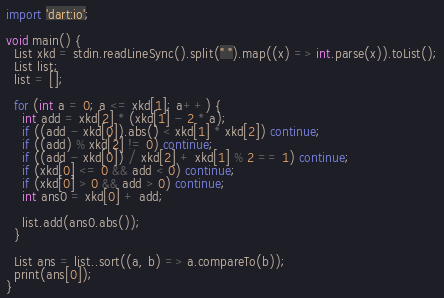Convert code to text. <code><loc_0><loc_0><loc_500><loc_500><_Dart_>import 'dart:io';

void main() {
  List xkd = stdin.readLineSync().split(" ").map((x) => int.parse(x)).toList();
  List list;
  list = [];

  for (int a = 0; a <= xkd[1]; a++) {
    int add = xkd[2] * (xkd[1] - 2 * a);
    if ((add - xkd[0]).abs() < xkd[1] * xkd[2]) continue;
    if ((add) % xkd[2] != 0) continue;
    if ((add - xkd[0]) / xkd[2] + xkd[1] % 2 == 1) continue;
    if (xkd[0] <= 0 && add < 0) continue;
    if (xkd[0] > 0 && add > 0) continue;
    int ans0 = xkd[0] + add;

    list.add(ans0.abs());
  }

  List ans = list..sort((a, b) => a.compareTo(b));
  print(ans[0]);
}</code> 